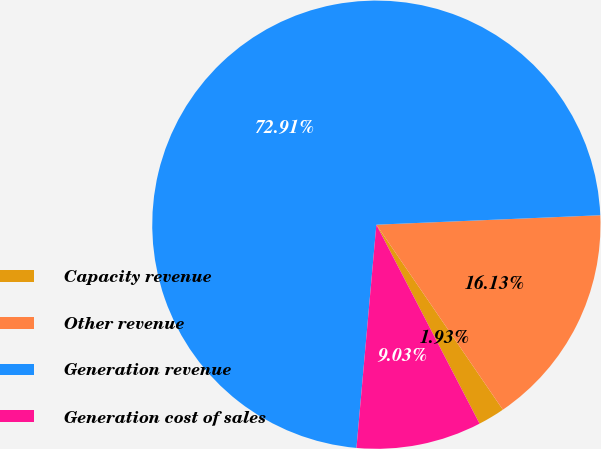<chart> <loc_0><loc_0><loc_500><loc_500><pie_chart><fcel>Capacity revenue<fcel>Other revenue<fcel>Generation revenue<fcel>Generation cost of sales<nl><fcel>1.93%<fcel>16.13%<fcel>72.92%<fcel>9.03%<nl></chart> 